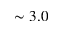<formula> <loc_0><loc_0><loc_500><loc_500>\sim 3 . 0</formula> 